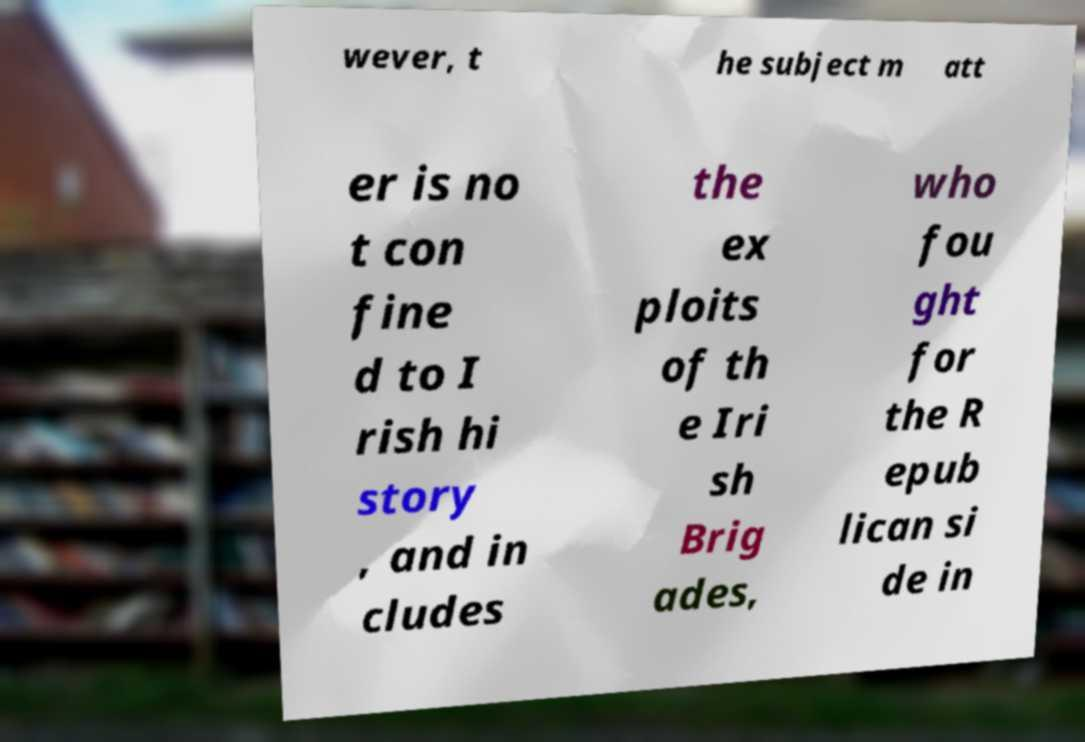For documentation purposes, I need the text within this image transcribed. Could you provide that? wever, t he subject m att er is no t con fine d to I rish hi story , and in cludes the ex ploits of th e Iri sh Brig ades, who fou ght for the R epub lican si de in 